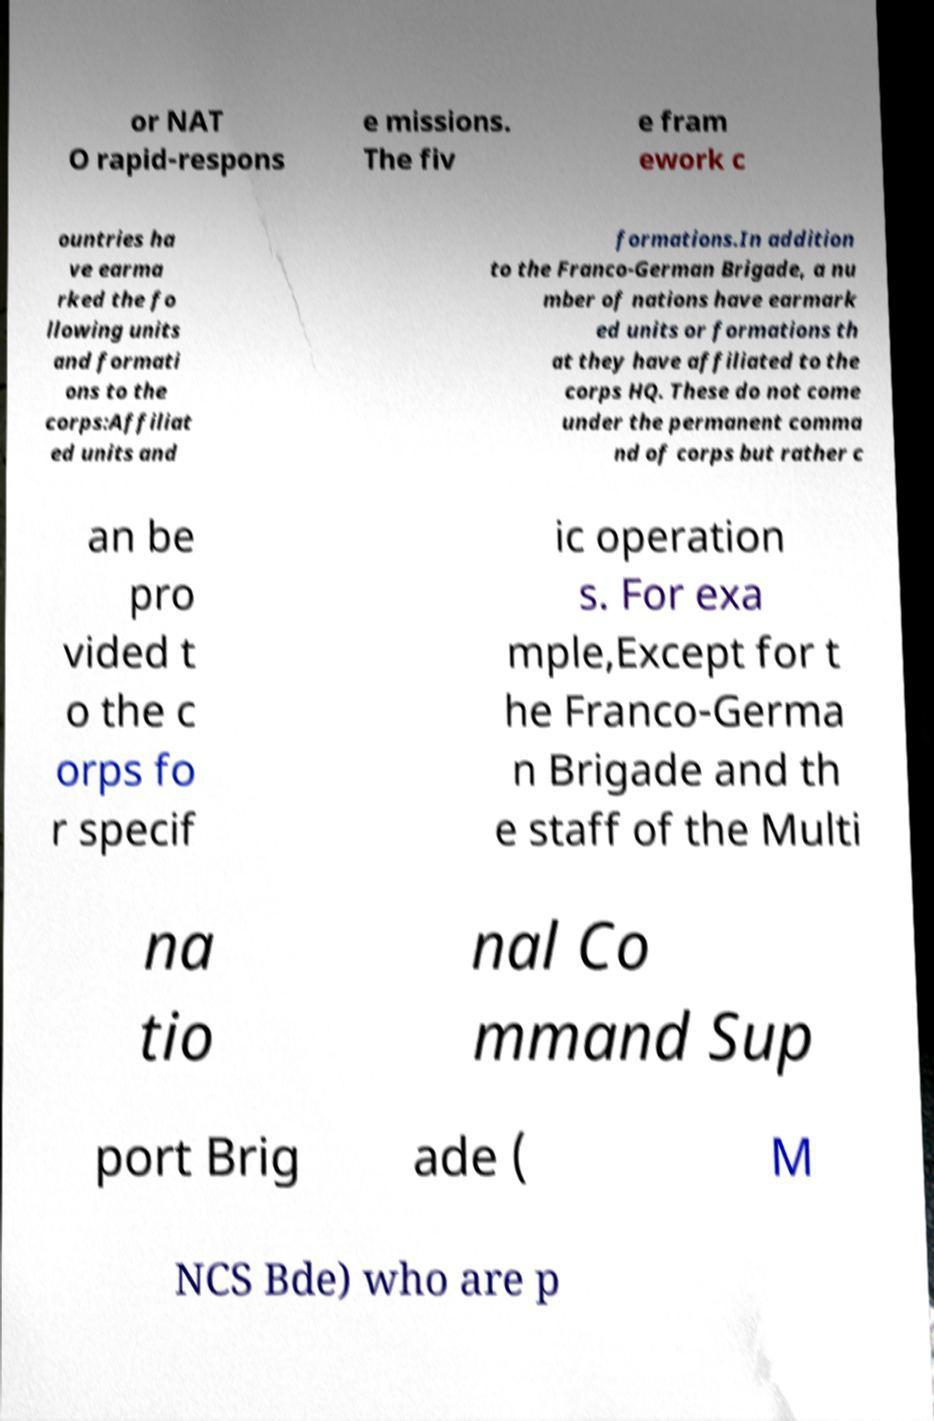Please read and relay the text visible in this image. What does it say? or NAT O rapid-respons e missions. The fiv e fram ework c ountries ha ve earma rked the fo llowing units and formati ons to the corps:Affiliat ed units and formations.In addition to the Franco-German Brigade, a nu mber of nations have earmark ed units or formations th at they have affiliated to the corps HQ. These do not come under the permanent comma nd of corps but rather c an be pro vided t o the c orps fo r specif ic operation s. For exa mple,Except for t he Franco-Germa n Brigade and th e staff of the Multi na tio nal Co mmand Sup port Brig ade ( M NCS Bde) who are p 